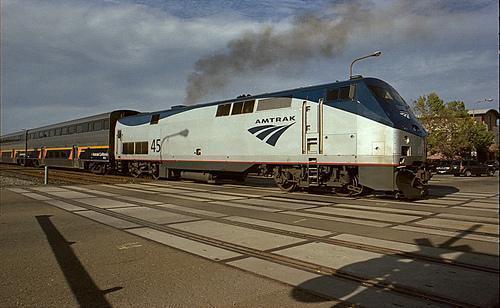How many trains are pictured?
Give a very brief answer. 1. How many train cars are blue and white?
Give a very brief answer. 1. 